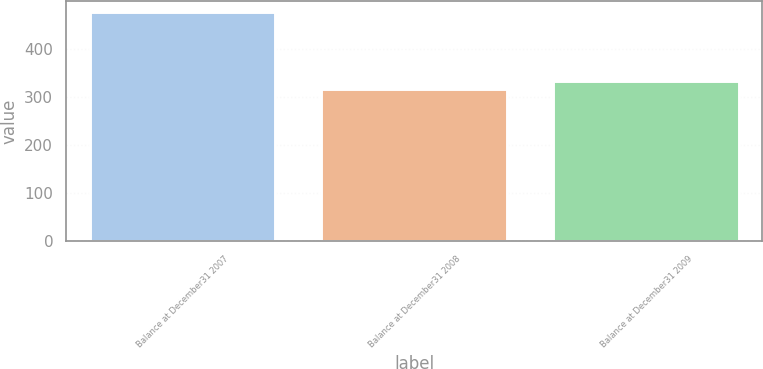Convert chart to OTSL. <chart><loc_0><loc_0><loc_500><loc_500><bar_chart><fcel>Balance at December31 2007<fcel>Balance at December31 2008<fcel>Balance at December31 2009<nl><fcel>476<fcel>317<fcel>332.9<nl></chart> 